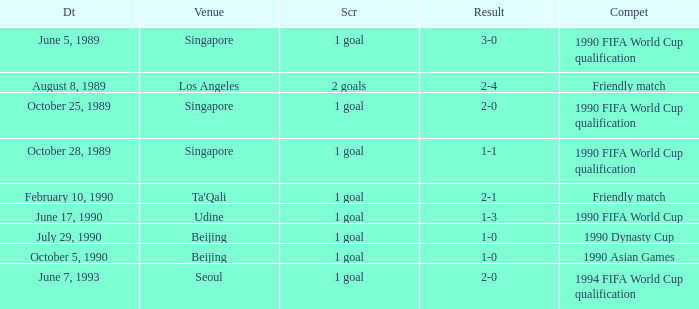What is the score of the match on July 29, 1990? 1 goal. 